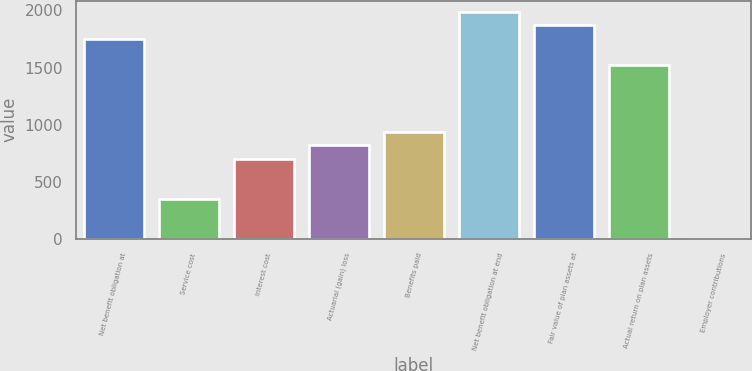<chart> <loc_0><loc_0><loc_500><loc_500><bar_chart><fcel>Net benefit obligation at<fcel>Service cost<fcel>Interest cost<fcel>Actuarial (gain) loss<fcel>Benefits paid<fcel>Net benefit obligation at end<fcel>Fair value of plan assets at<fcel>Actual return on plan assets<fcel>Employer contributions<nl><fcel>1754<fcel>352.4<fcel>702.8<fcel>819.6<fcel>936.4<fcel>1987.6<fcel>1870.8<fcel>1520.4<fcel>2<nl></chart> 